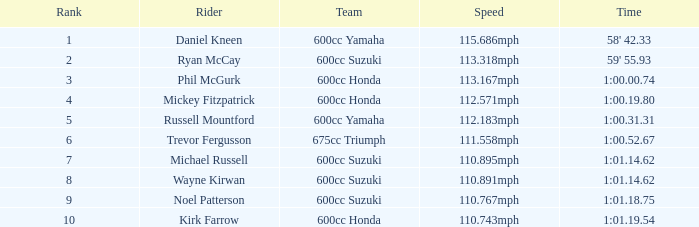What is the total number of ranks michael russell holds as a rider? 7.0. Would you mind parsing the complete table? {'header': ['Rank', 'Rider', 'Team', 'Speed', 'Time'], 'rows': [['1', 'Daniel Kneen', '600cc Yamaha', '115.686mph', "58' 42.33"], ['2', 'Ryan McCay', '600cc Suzuki', '113.318mph', "59' 55.93"], ['3', 'Phil McGurk', '600cc Honda', '113.167mph', '1:00.00.74'], ['4', 'Mickey Fitzpatrick', '600cc Honda', '112.571mph', '1:00.19.80'], ['5', 'Russell Mountford', '600cc Yamaha', '112.183mph', '1:00.31.31'], ['6', 'Trevor Fergusson', '675cc Triumph', '111.558mph', '1:00.52.67'], ['7', 'Michael Russell', '600cc Suzuki', '110.895mph', '1:01.14.62'], ['8', 'Wayne Kirwan', '600cc Suzuki', '110.891mph', '1:01.14.62'], ['9', 'Noel Patterson', '600cc Suzuki', '110.767mph', '1:01.18.75'], ['10', 'Kirk Farrow', '600cc Honda', '110.743mph', '1:01.19.54']]} 